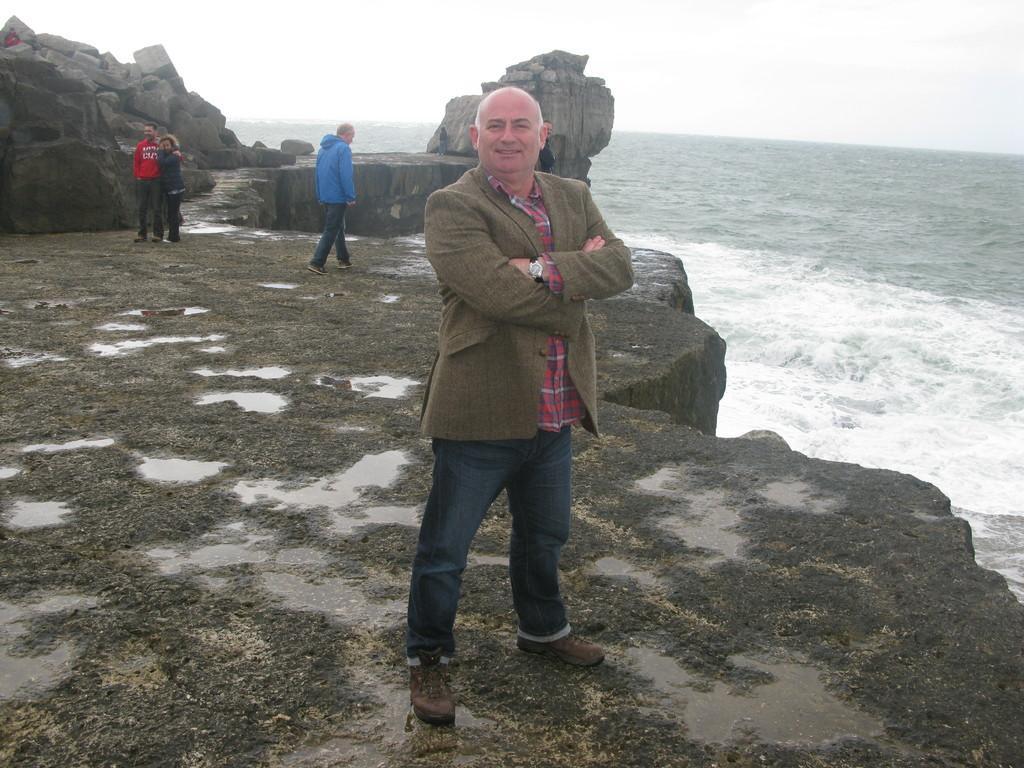Describe this image in one or two sentences. In the picture we can see the rock surface with some parts of water on it and a man standing, and behind him we can see another man walking and besides, we can see a man and a woman standing together near the rocks and besides we can see the water surface and in the background we can see the sky. 